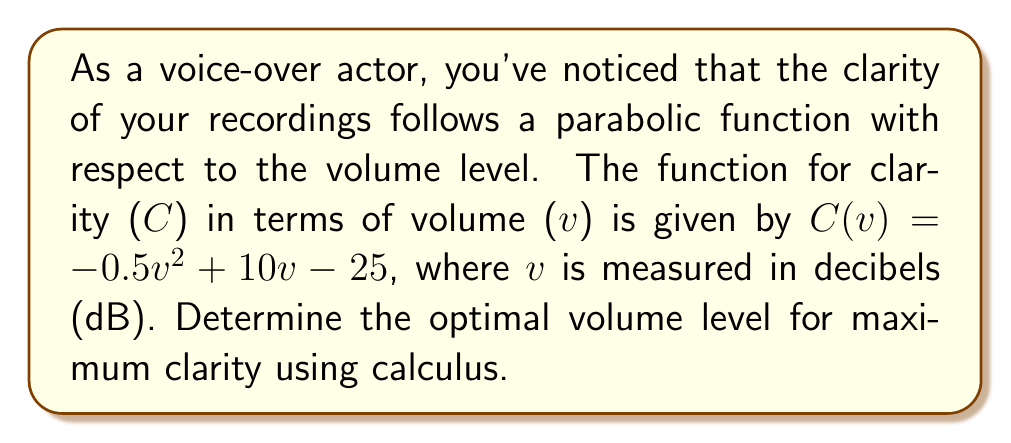Could you help me with this problem? To find the optimal volume level for maximum clarity, we need to find the maximum point of the given function. This can be done by following these steps:

1. Find the derivative of the function:
   $C(v) = -0.5v^2 + 10v - 25$
   $C'(v) = -v + 10$

2. Set the derivative equal to zero to find the critical point:
   $C'(v) = 0$
   $-v + 10 = 0$
   $v = 10$

3. Verify that this critical point is a maximum by checking the second derivative:
   $C''(v) = -1$
   Since $C''(v)$ is negative, the critical point is indeed a maximum.

4. Therefore, the optimal volume level for maximum clarity is 10 dB.

5. To find the maximum clarity value, substitute v = 10 into the original function:
   $C(10) = -0.5(10)^2 + 10(10) - 25$
   $= -50 + 100 - 25$
   $= 25$

Thus, the maximum clarity of 25 units is achieved at a volume level of 10 dB.
Answer: 10 dB 